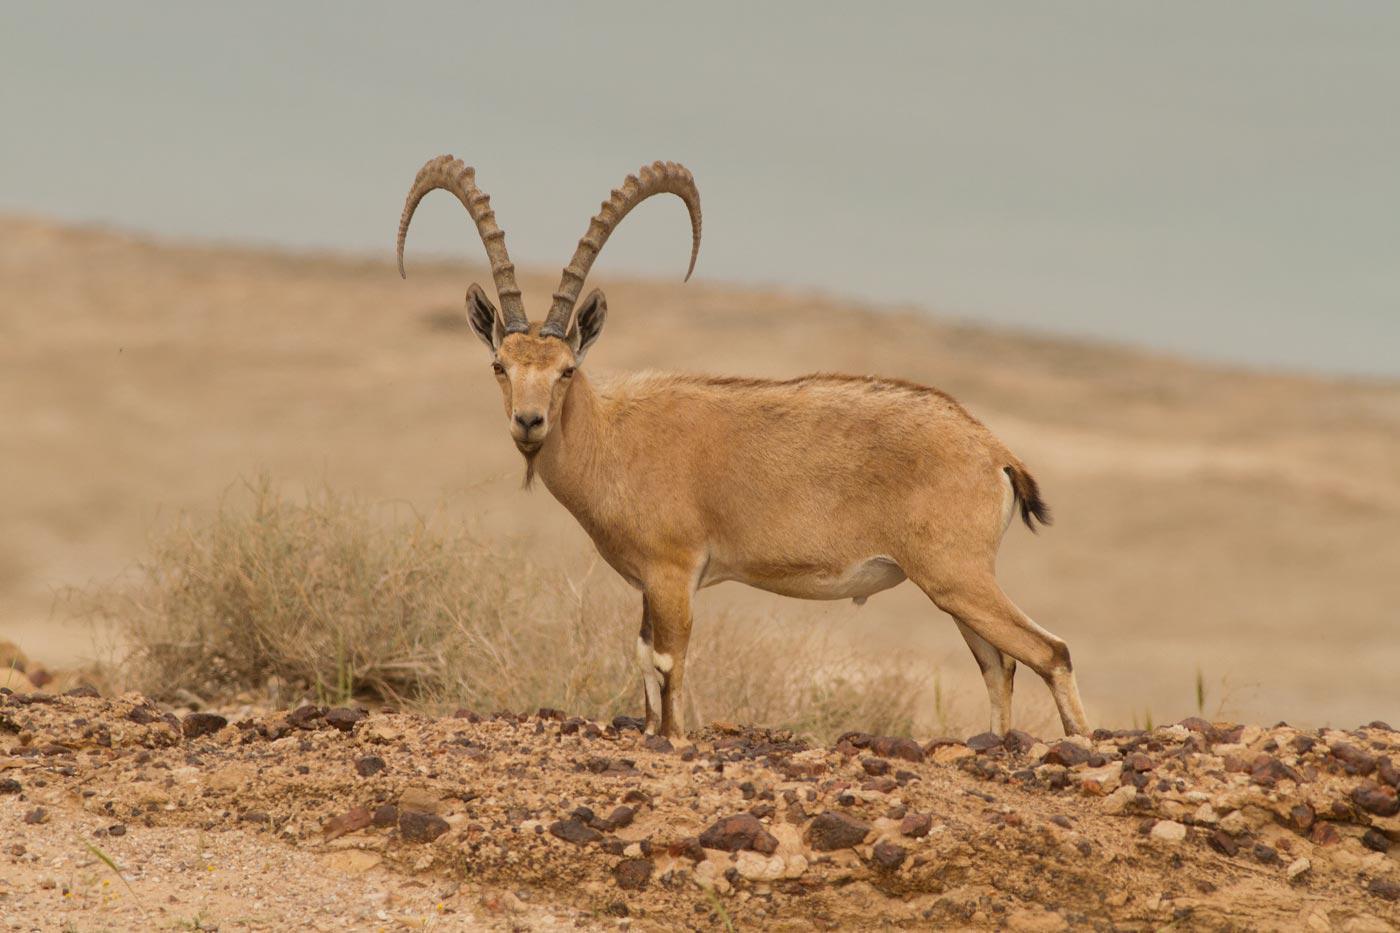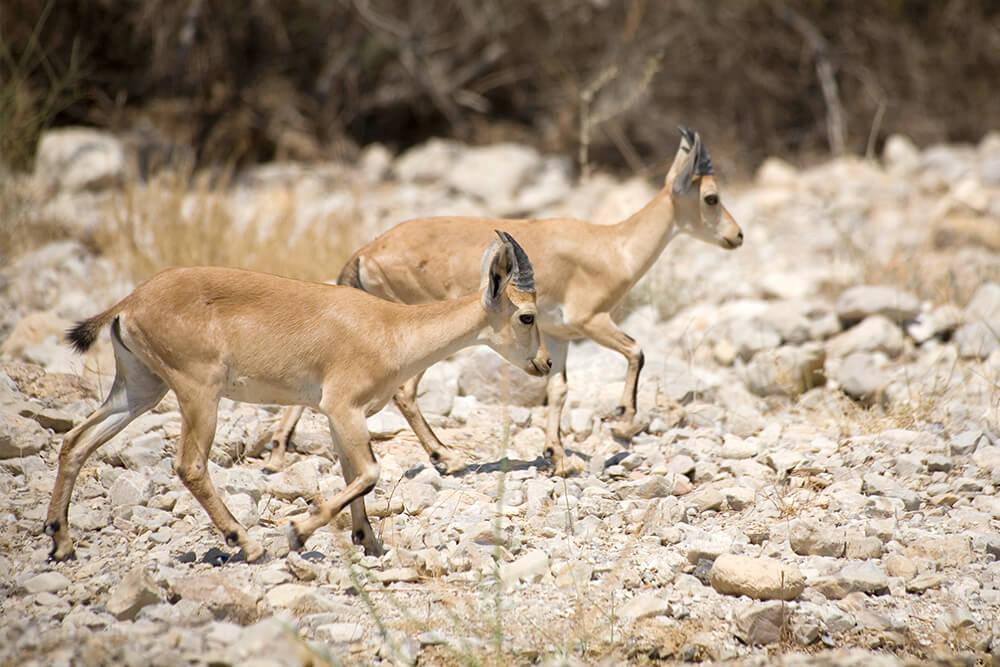The first image is the image on the left, the second image is the image on the right. For the images shown, is this caption "One of the paired images features exactly two animals." true? Answer yes or no. Yes. 